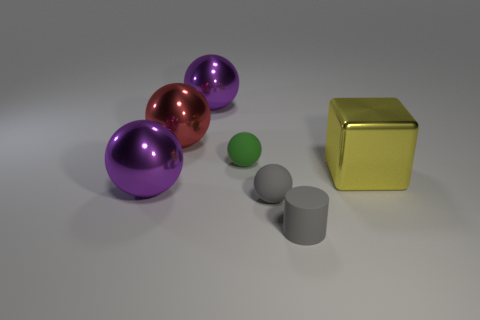How many other objects are the same color as the small matte cylinder?
Offer a very short reply. 1. What size is the rubber object that is the same color as the cylinder?
Ensure brevity in your answer.  Small. How many objects are either big purple rubber things or purple balls?
Make the answer very short. 2. There is a rubber ball that is in front of the green object; does it have the same color as the thing that is behind the red thing?
Your answer should be compact. No. How many other objects are the same shape as the yellow metallic thing?
Offer a terse response. 0. Is there a small blue cylinder?
Make the answer very short. No. How many objects are large cubes or gray spheres in front of the big yellow shiny block?
Your answer should be compact. 2. Does the purple ball that is behind the yellow metallic block have the same size as the big red metallic ball?
Ensure brevity in your answer.  Yes. What number of other things are the same size as the gray rubber cylinder?
Ensure brevity in your answer.  2. What color is the small cylinder?
Your response must be concise. Gray. 